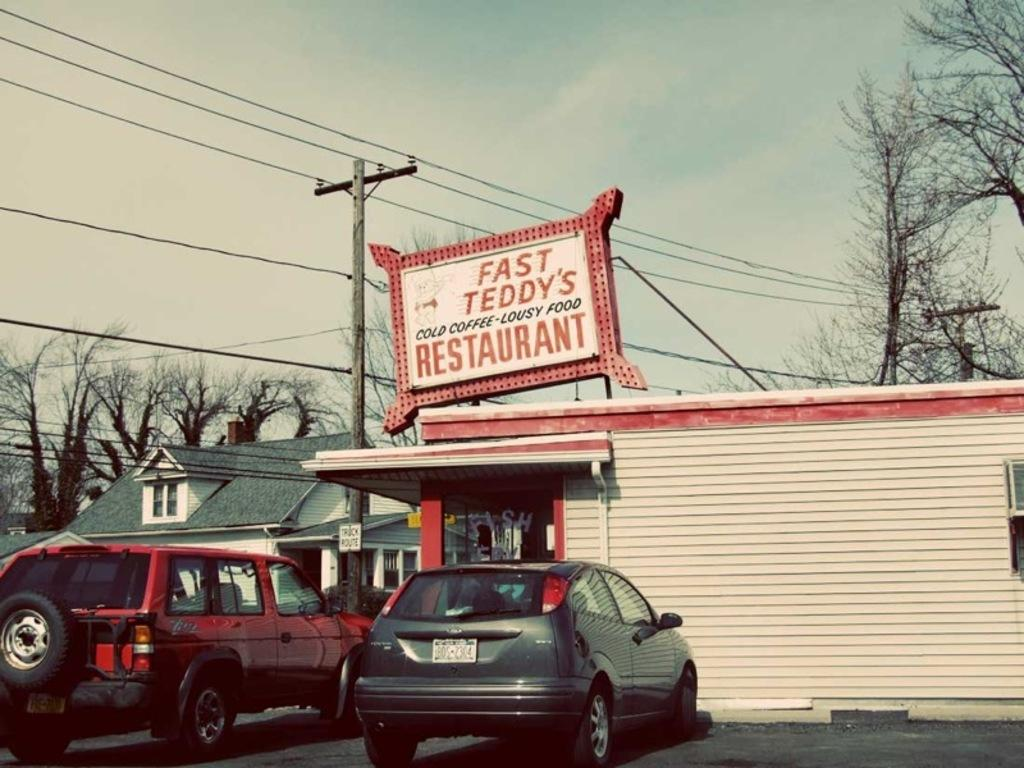What can be seen parked in the image? There are vehicles parked in the image. Where are the vehicles located in relation to a building? The vehicles are outside a restaurant. What type of natural elements can be seen in the image? Trees are present in the image. What man-made structure is visible in the image? There is an electric pole in the image. What is connected to the electric pole? Wires are visible in the image. Can you see any rabbits hopping around the vehicles in the image? There are no rabbits present in the image; it only features vehicles parked outside a restaurant, trees, an electric pole, and wires. 